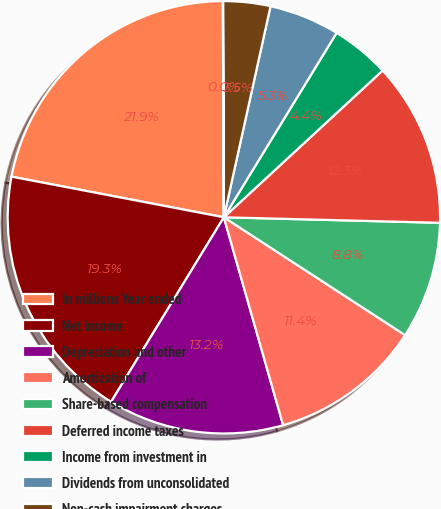<chart> <loc_0><loc_0><loc_500><loc_500><pie_chart><fcel>In millions Year ended<fcel>Net income<fcel>Depreciation and other<fcel>Amortization of<fcel>Share-based compensation<fcel>Deferred income taxes<fcel>Income from investment in<fcel>Dividends from unconsolidated<fcel>Non-cash impairment charges<fcel>Other operating activities<nl><fcel>21.91%<fcel>19.28%<fcel>13.15%<fcel>11.4%<fcel>8.77%<fcel>12.28%<fcel>4.39%<fcel>5.27%<fcel>3.52%<fcel>0.02%<nl></chart> 